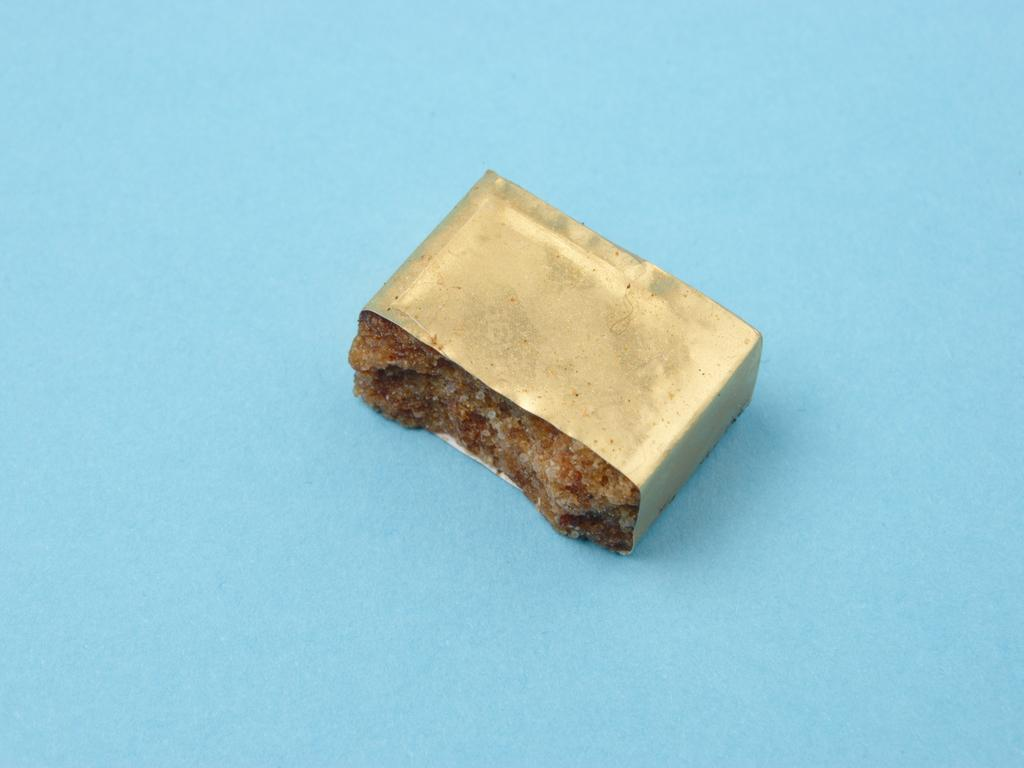What is the main object in the image? There is a gold and brown color object in the image. What is the color of the surface the object is placed on? The object is on a blue color surface. What news is being reported by the finger in the image? There is no finger present in the image, and therefore no news can be reported. How many bikes are visible in the image? There are no bikes present in the image. 